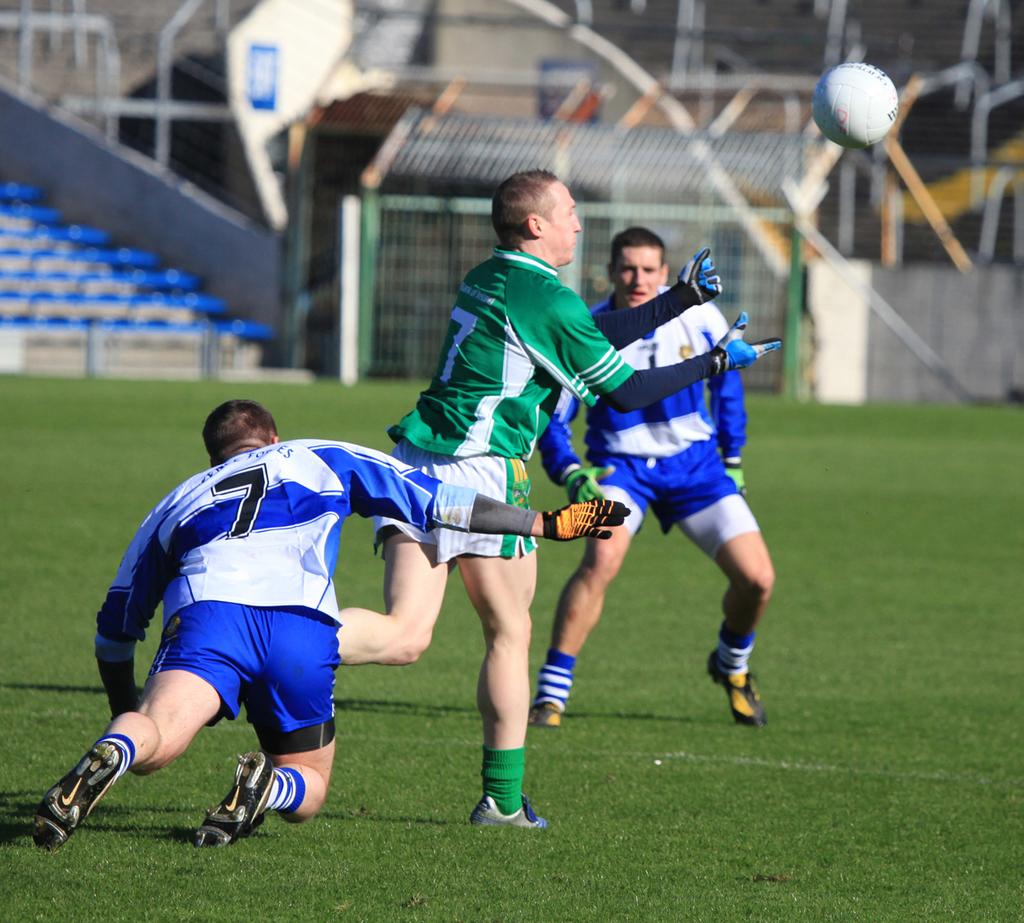Where was the image taken? The image was taken at a football stadium. What activity is being performed by the three persons in the image? The three persons are playing football in the image. On what surface is the football game taking place? The football game is taking place on a ground. What type of chess pieces can be seen on the field in the image? There are no chess pieces present in the image; it features a football game. Who is the representative of the opposing team in the image? There is no mention of teams or representatives in the image; it only shows three persons playing football. 